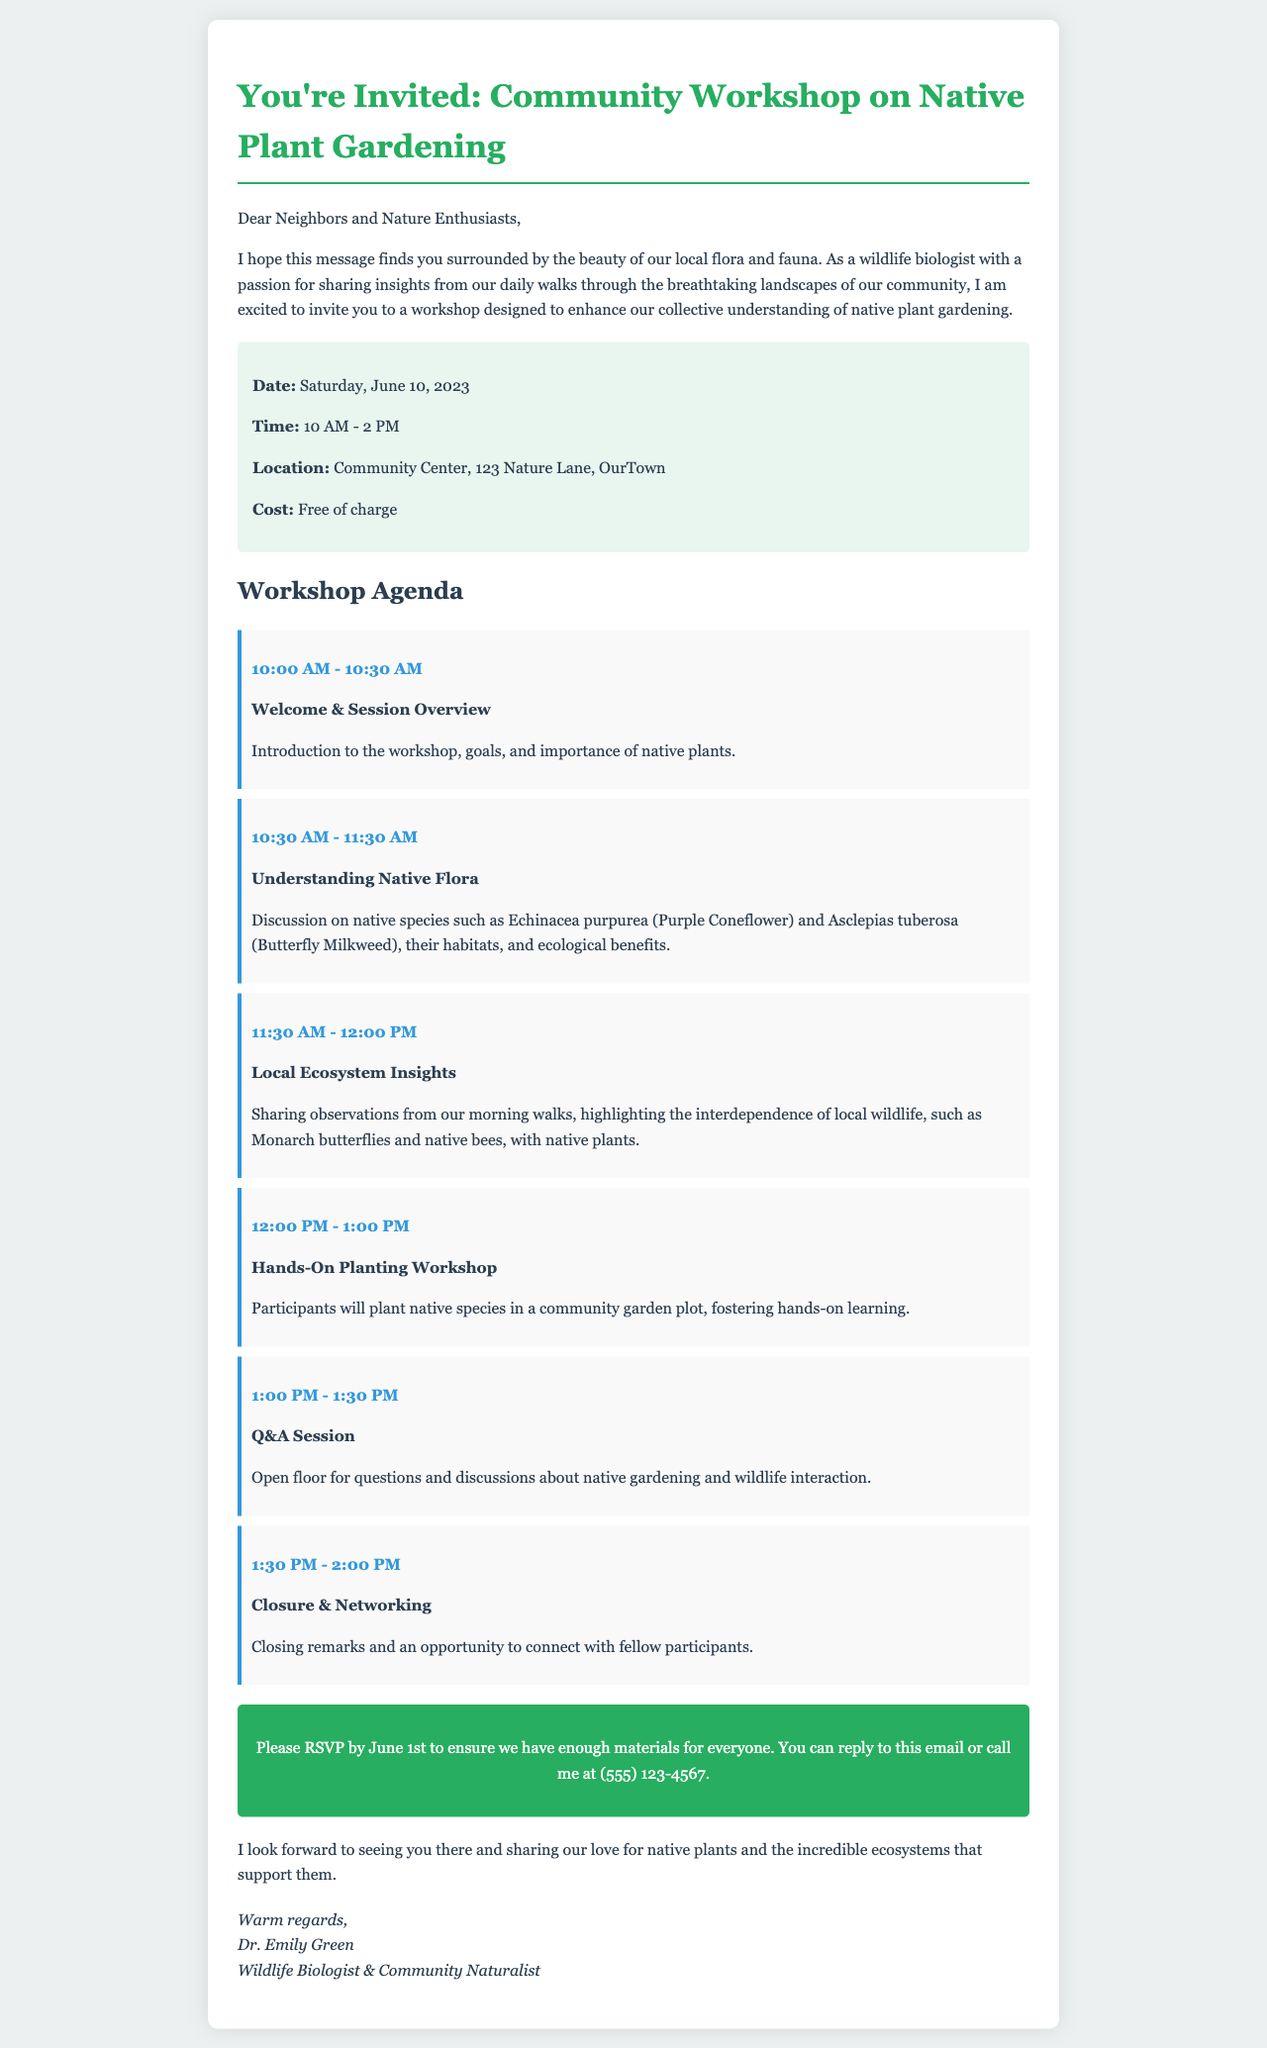What is the date of the workshop? The document specifies the date of the workshop in the details section.
Answer: Saturday, June 10, 2023 What is the location of the workshop? The location is provided in the details section of the document.
Answer: Community Center, 123 Nature Lane, OurTown How long is the workshop scheduled to last? The start and end times of the workshop indicate its duration.
Answer: 4 hours What is the cost to attend the workshop? The cost is mentioned in the details section.
Answer: Free of charge Which native plant species will be discussed? The agenda lists specific plant species being covered during the workshop.
Answer: Echinacea purpurea, Asclepias tuberosa What time does the Q&A session start? The schedule in the agenda shows the timing of each session.
Answer: 1:00 PM Why is understanding native plants important? This is addressed in the welcome session overview in the agenda.
Answer: It enhances our collective understanding of native plant gardening How can participants RSVP for the workshop? The call-to-action section provides instructions for RSVP.
Answer: Reply to this email or call (555) 123-4567 What topic will be covered during the 11:30 AM slot? The agenda provides specific topics for each time slot in the schedule.
Answer: Local Ecosystem Insights 